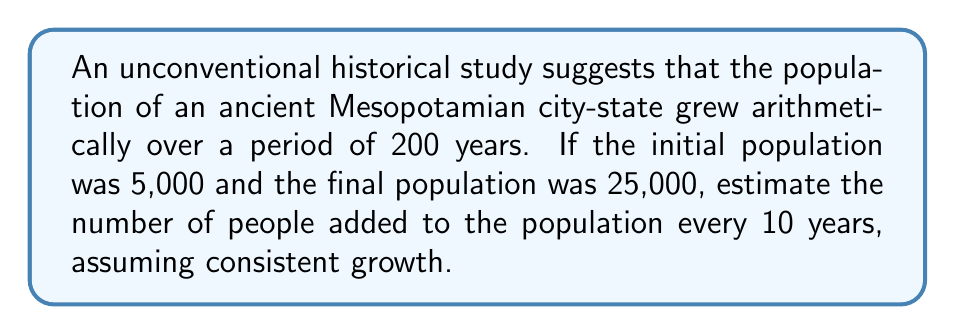Provide a solution to this math problem. Let's approach this step-by-step:

1) We're dealing with an arithmetic sequence, where the population increases by a constant amount every 10 years.

2) Let's define our variables:
   $a_1 = 5,000$ (initial population)
   $a_n = 25,000$ (final population)
   $n = 21$ (number of terms, as 200 years divided by 10-year intervals gives 20 intervals, plus the initial population)
   $d$ = common difference (what we're trying to find)

3) The formula for the nth term of an arithmetic sequence is:
   $$a_n = a_1 + (n-1)d$$

4) Substituting our known values:
   $$25,000 = 5,000 + (21-1)d$$

5) Simplify:
   $$25,000 = 5,000 + 20d$$

6) Subtract 5,000 from both sides:
   $$20,000 = 20d$$

7) Divide both sides by 20:
   $$1,000 = d$$

Therefore, the population increased by 1,000 people every 10 years.
Answer: 1,000 people per 10 years 